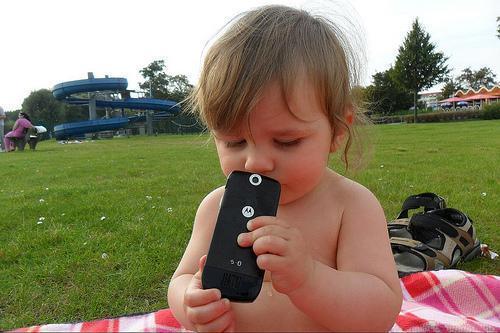How many shoes are sitting behind the toddler?
Give a very brief answer. 2. How many people are identifiable in the photo?
Give a very brief answer. 2. 